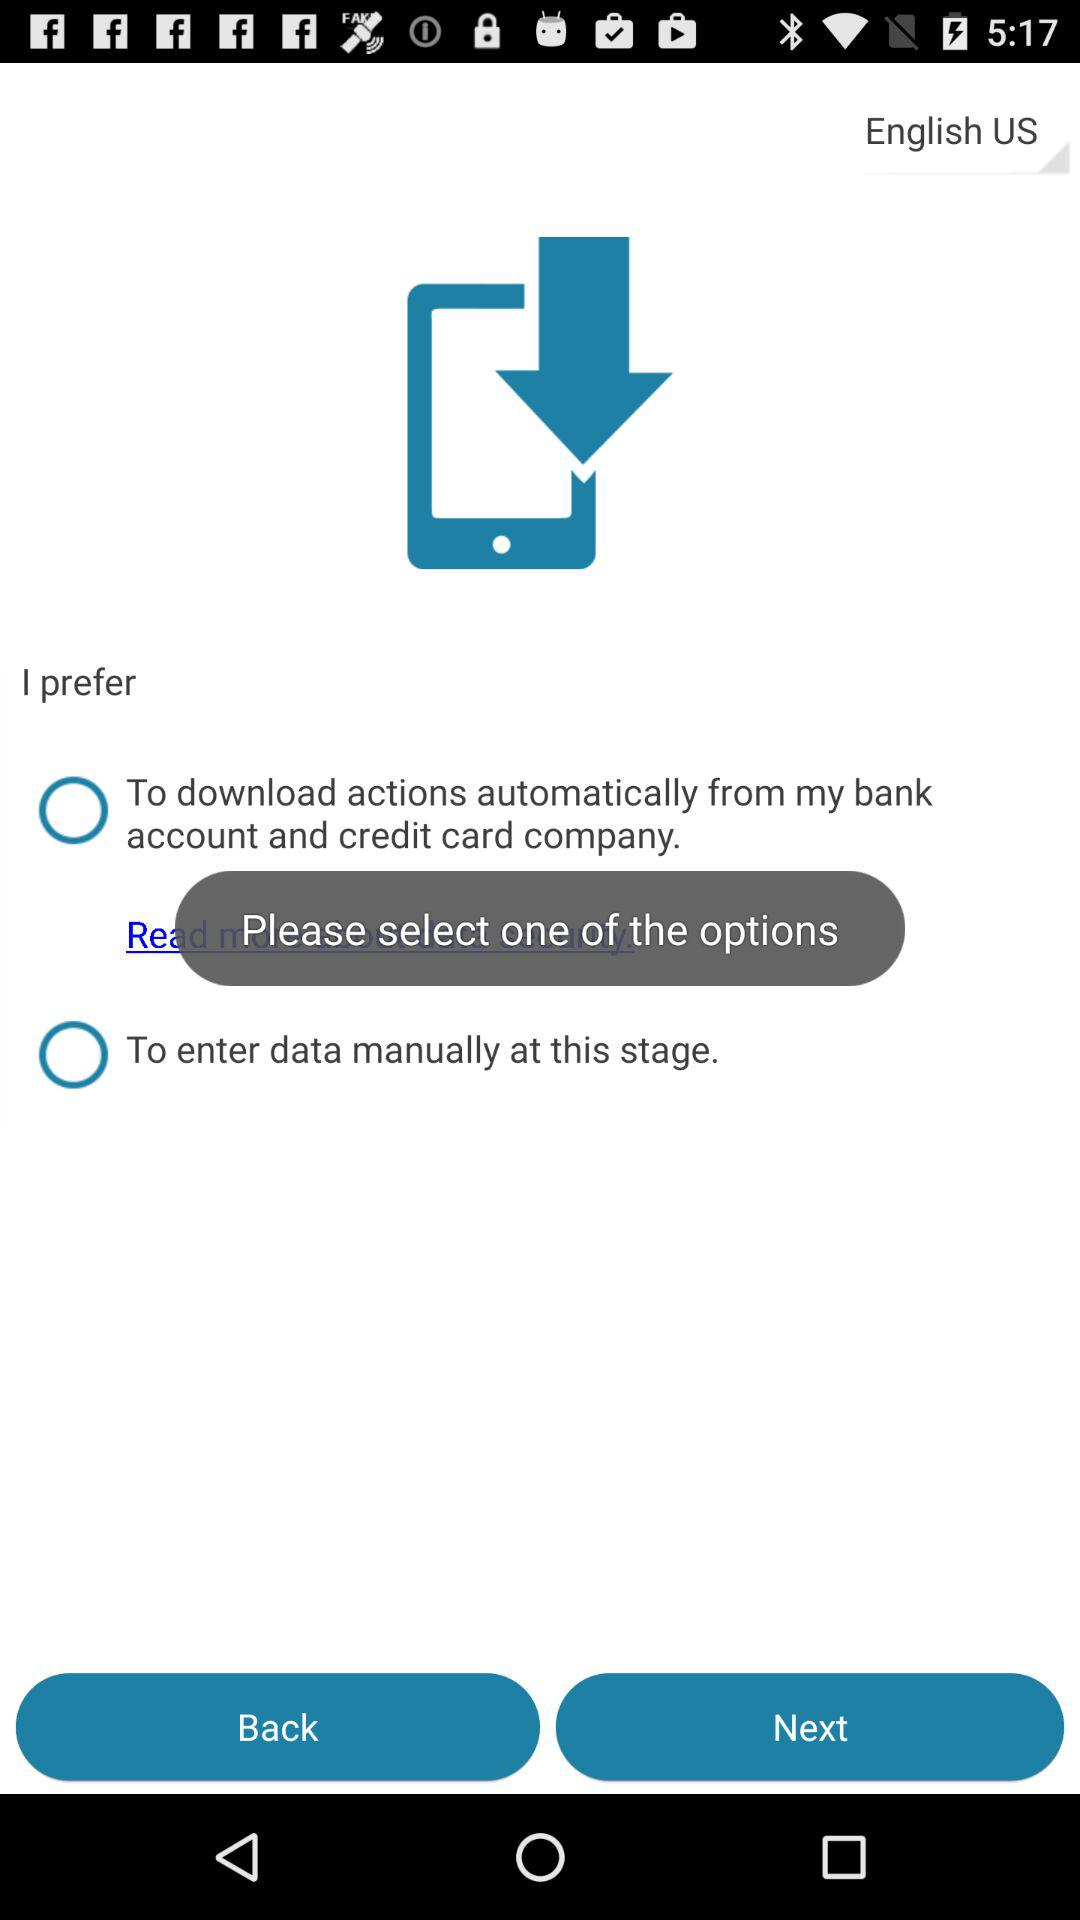How many options are there for how to add transactions?
Answer the question using a single word or phrase. 2 